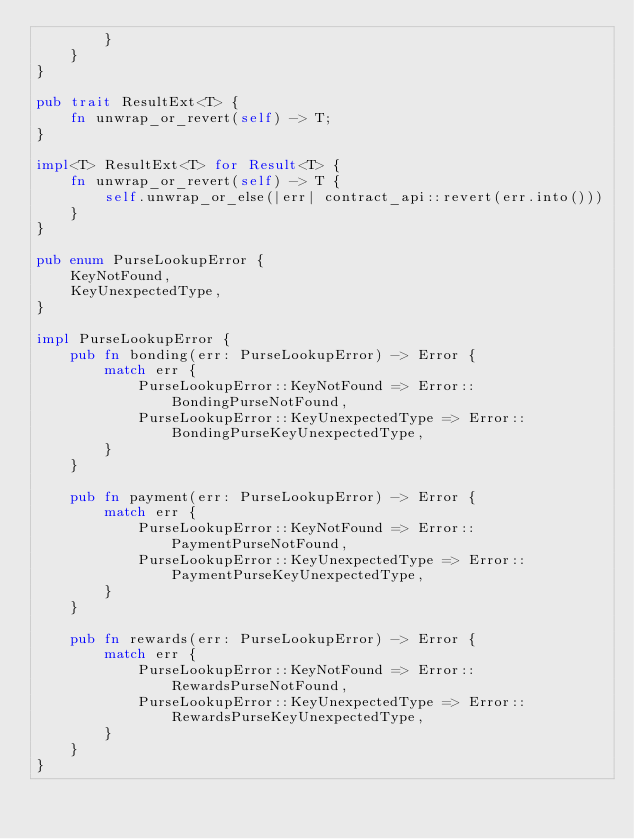<code> <loc_0><loc_0><loc_500><loc_500><_Rust_>        }
    }
}

pub trait ResultExt<T> {
    fn unwrap_or_revert(self) -> T;
}

impl<T> ResultExt<T> for Result<T> {
    fn unwrap_or_revert(self) -> T {
        self.unwrap_or_else(|err| contract_api::revert(err.into()))
    }
}

pub enum PurseLookupError {
    KeyNotFound,
    KeyUnexpectedType,
}

impl PurseLookupError {
    pub fn bonding(err: PurseLookupError) -> Error {
        match err {
            PurseLookupError::KeyNotFound => Error::BondingPurseNotFound,
            PurseLookupError::KeyUnexpectedType => Error::BondingPurseKeyUnexpectedType,
        }
    }

    pub fn payment(err: PurseLookupError) -> Error {
        match err {
            PurseLookupError::KeyNotFound => Error::PaymentPurseNotFound,
            PurseLookupError::KeyUnexpectedType => Error::PaymentPurseKeyUnexpectedType,
        }
    }

    pub fn rewards(err: PurseLookupError) -> Error {
        match err {
            PurseLookupError::KeyNotFound => Error::RewardsPurseNotFound,
            PurseLookupError::KeyUnexpectedType => Error::RewardsPurseKeyUnexpectedType,
        }
    }
}
</code> 